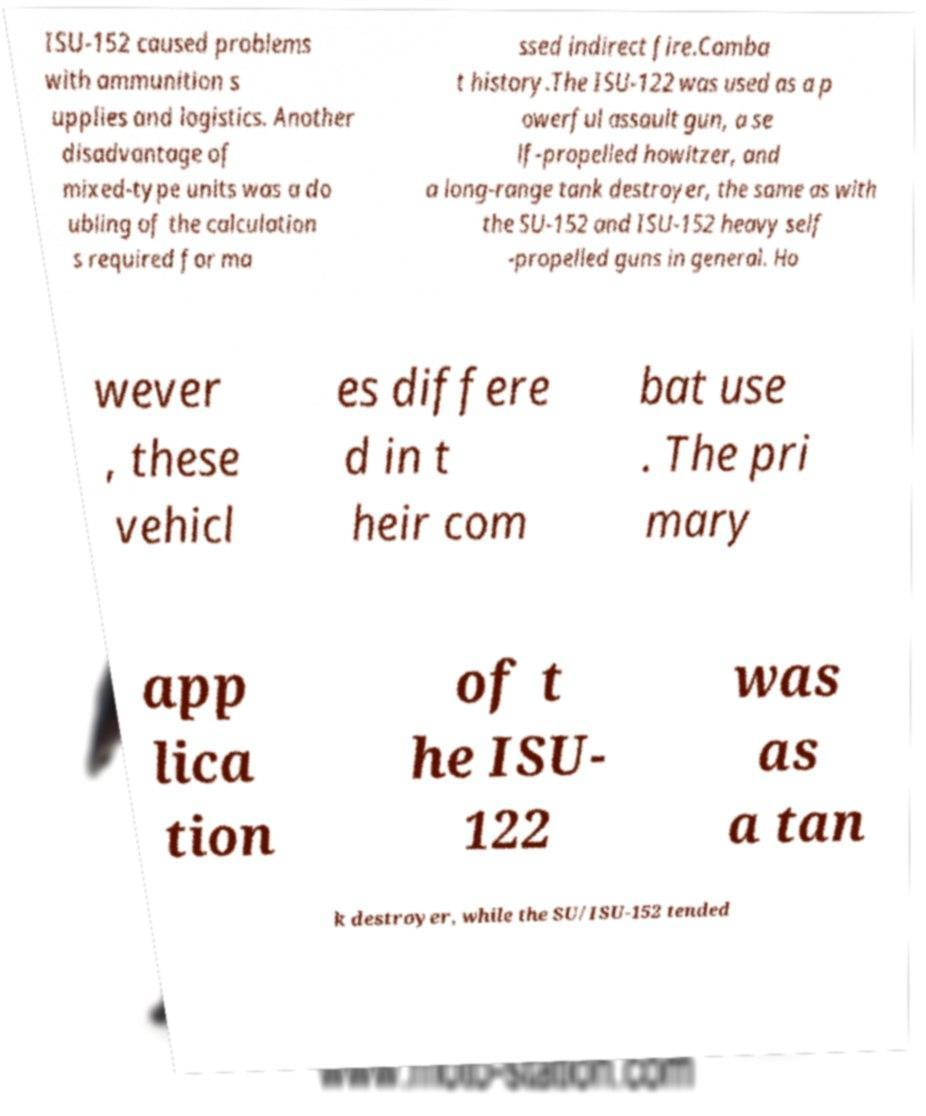Could you assist in decoding the text presented in this image and type it out clearly? ISU-152 caused problems with ammunition s upplies and logistics. Another disadvantage of mixed-type units was a do ubling of the calculation s required for ma ssed indirect fire.Comba t history.The ISU-122 was used as a p owerful assault gun, a se lf-propelled howitzer, and a long-range tank destroyer, the same as with the SU-152 and ISU-152 heavy self -propelled guns in general. Ho wever , these vehicl es differe d in t heir com bat use . The pri mary app lica tion of t he ISU- 122 was as a tan k destroyer, while the SU/ISU-152 tended 